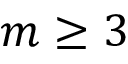Convert formula to latex. <formula><loc_0><loc_0><loc_500><loc_500>m \geq 3</formula> 